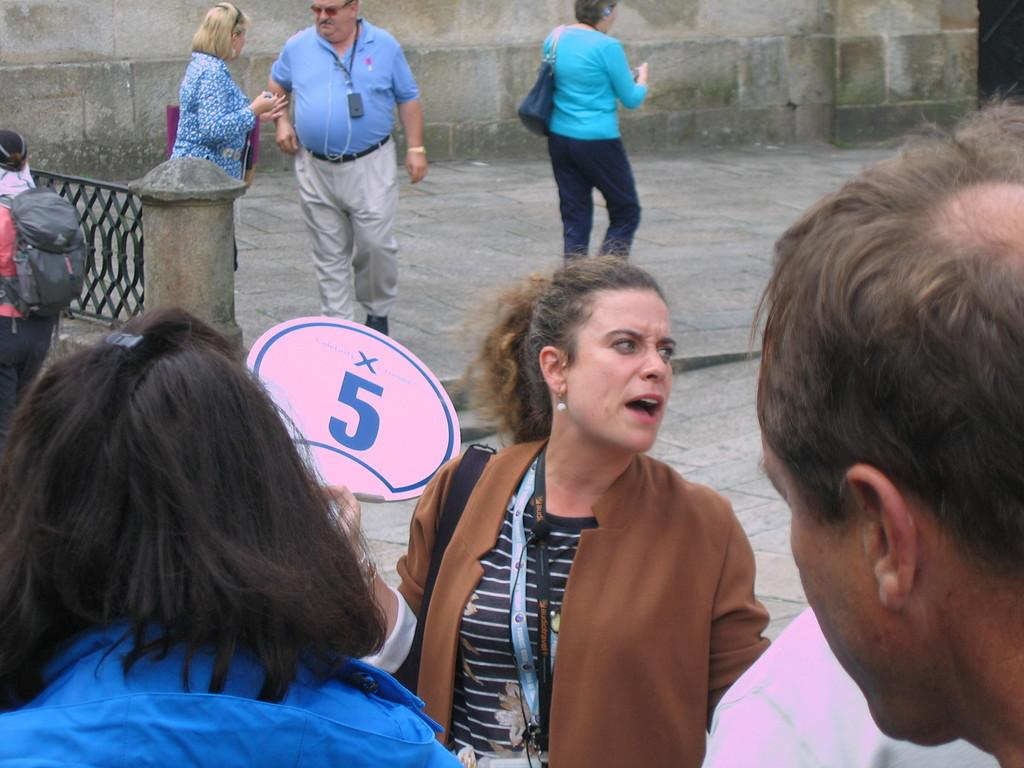What are the people in the image doing? The people in the image are standing on the ground. Can you describe the woman in the image? The woman in the image is holding a placard. What is written on the placard? The placard has the number "5" written on it. What action is the woman taking to stop the traffic in the image? There is no indication in the image that the woman is trying to stop traffic, and no traffic is visible in the image. 